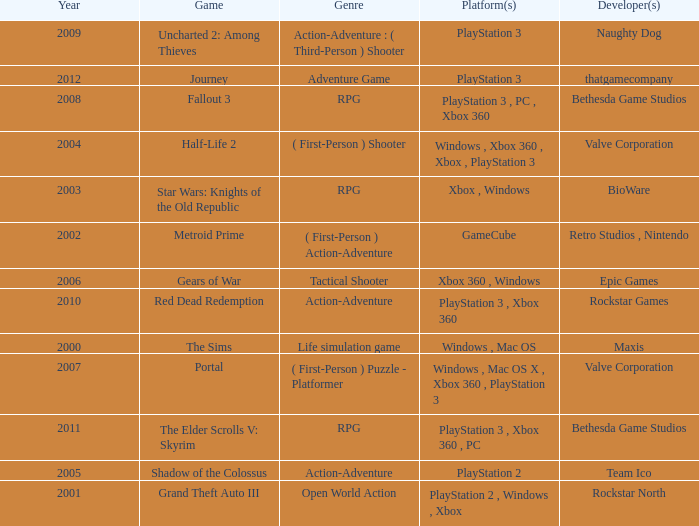What game was in 2001? Grand Theft Auto III. 